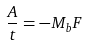Convert formula to latex. <formula><loc_0><loc_0><loc_500><loc_500>\frac { A } { t } = - M _ { b } F</formula> 